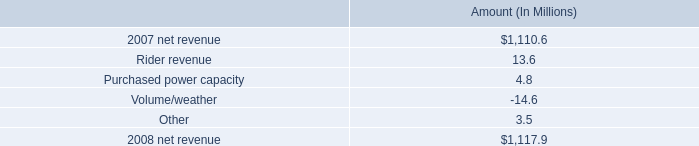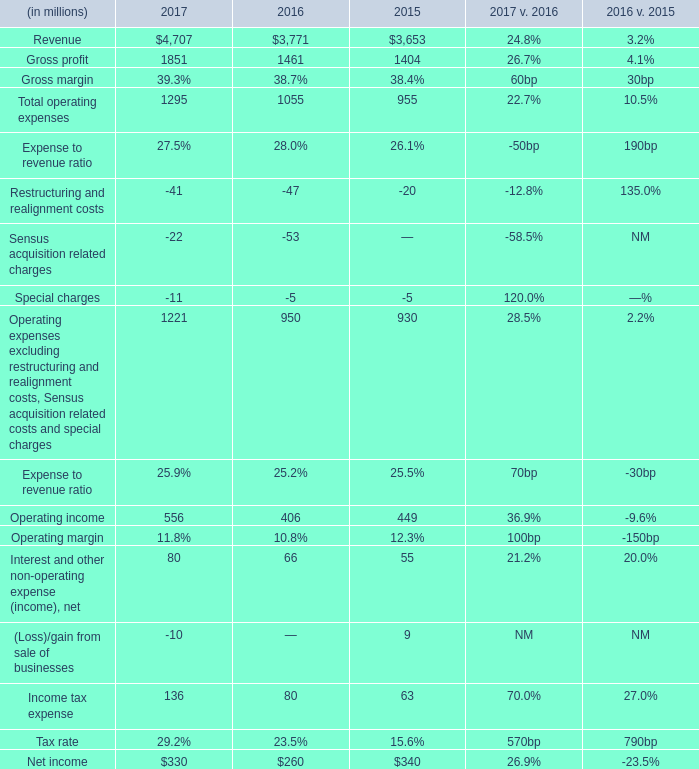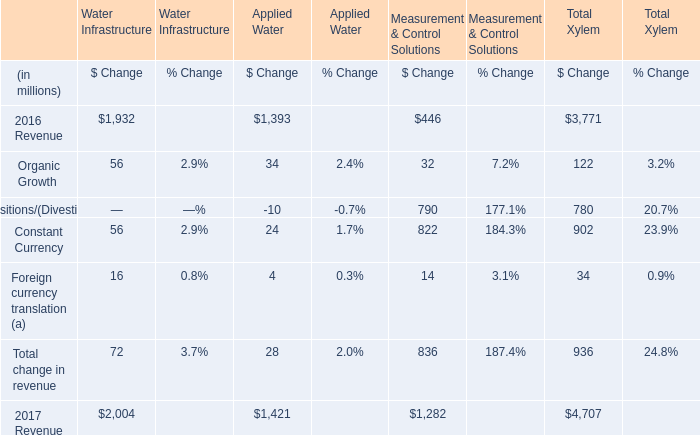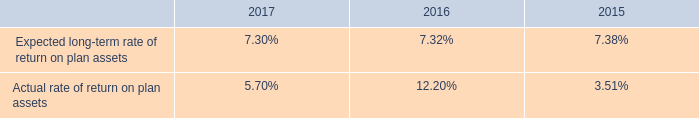As As the chart 2 shows,what was the value of Total change in revenue for Total Xylem ? (in million) 
Answer: 936. 